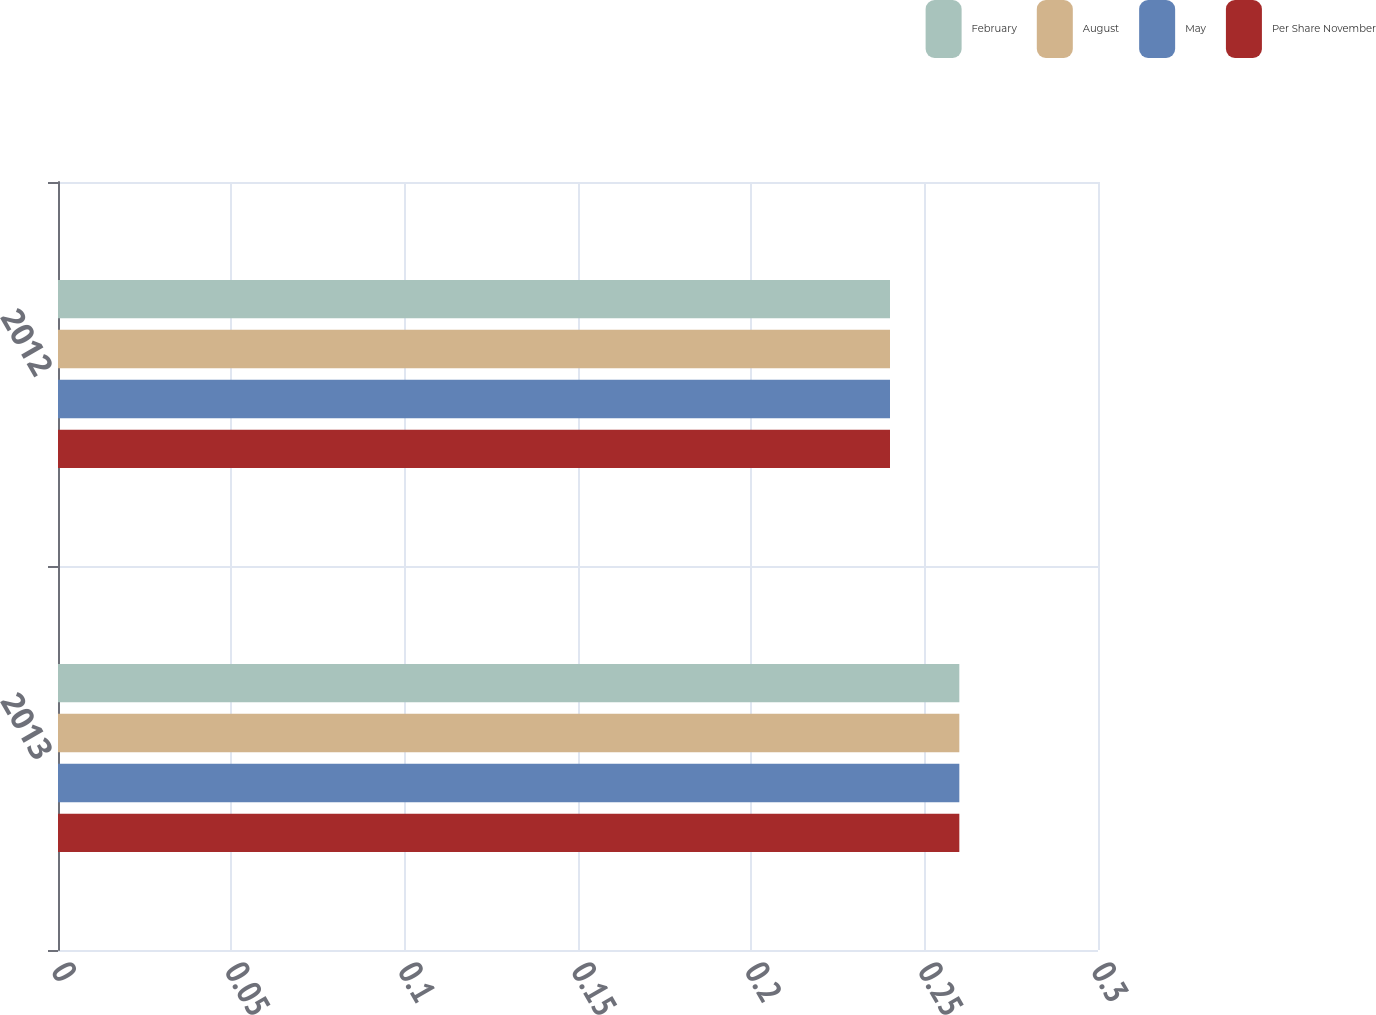<chart> <loc_0><loc_0><loc_500><loc_500><stacked_bar_chart><ecel><fcel>2013<fcel>2012<nl><fcel>February<fcel>0.26<fcel>0.24<nl><fcel>August<fcel>0.26<fcel>0.24<nl><fcel>May<fcel>0.26<fcel>0.24<nl><fcel>Per Share November<fcel>0.26<fcel>0.24<nl></chart> 